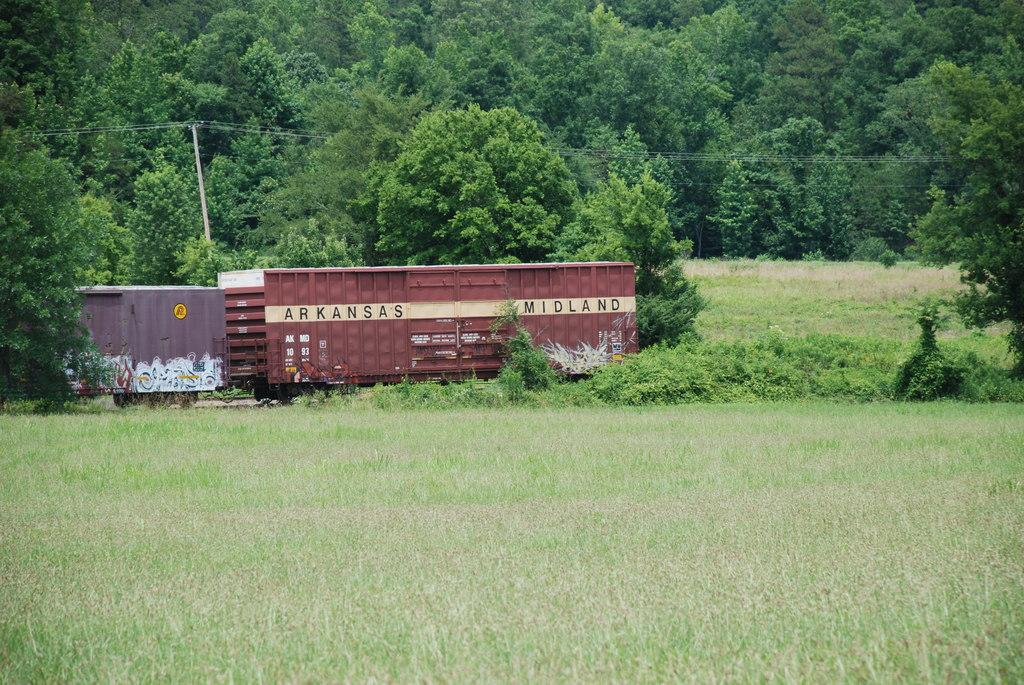What type of vegetation can be seen in the image? There are trees and plants in the image. What covers the ground in the image? There is grass on the ground in the image. What else can be seen in the image besides vegetation? There are containers with text in the image. What type of zinc material is used to make the wing in the image? There is no zinc material or wing present in the image. How can you obtain credit for the image? The image does not involve any credit system or transactions. 